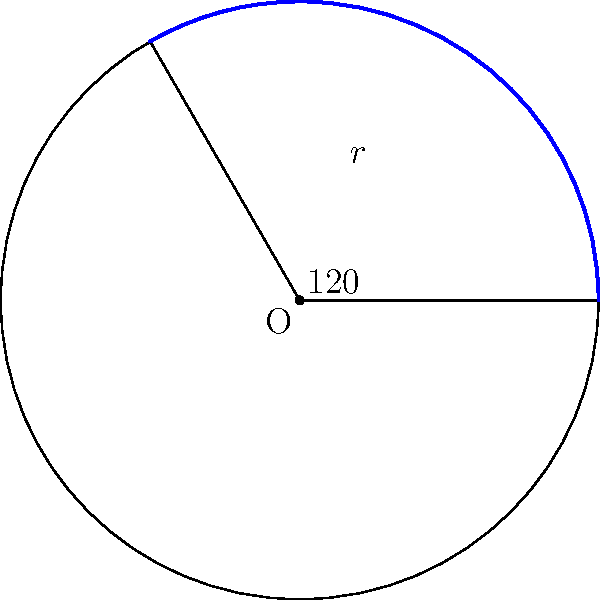As a literary agent preparing to publish a persuasive writing textbook, you encounter a geometry problem that could serve as an analogy for crafting compelling arguments. In the diagram, there's a circle with radius $r = 3$ units and a central angle of $120°$. What is the length of the blue arc, rounded to two decimal places? To solve this problem, we'll use the formula for arc length and follow these steps:

1) The formula for arc length is:
   $s = r\theta$
   Where $s$ is the arc length, $r$ is the radius, and $\theta$ is the central angle in radians.

2) We're given the radius $r = 3$ units and the central angle of $120°$.

3) We need to convert the angle from degrees to radians:
   $\theta = 120° \times \frac{\pi}{180°} = \frac{2\pi}{3}$ radians

4) Now we can substitute these values into our formula:
   $s = r\theta = 3 \times \frac{2\pi}{3} = 2\pi$

5) Calculate this value:
   $2\pi \approx 6.2831853...$

6) Rounding to two decimal places:
   $6.28$ units

This process of methodically working through steps to reach a conclusion mirrors the structure of a well-crafted persuasive argument, demonstrating the interconnectedness of mathematical and rhetorical thinking.
Answer: $6.28$ units 